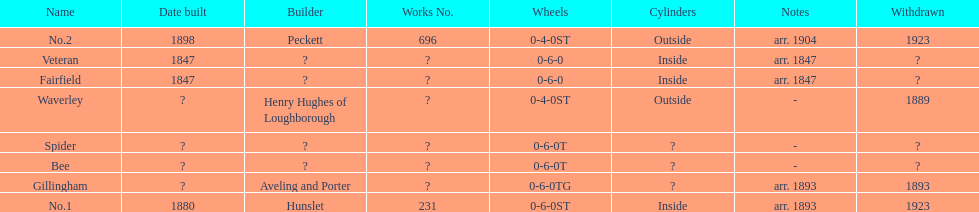Were there more with inside or outside cylinders? Inside. 